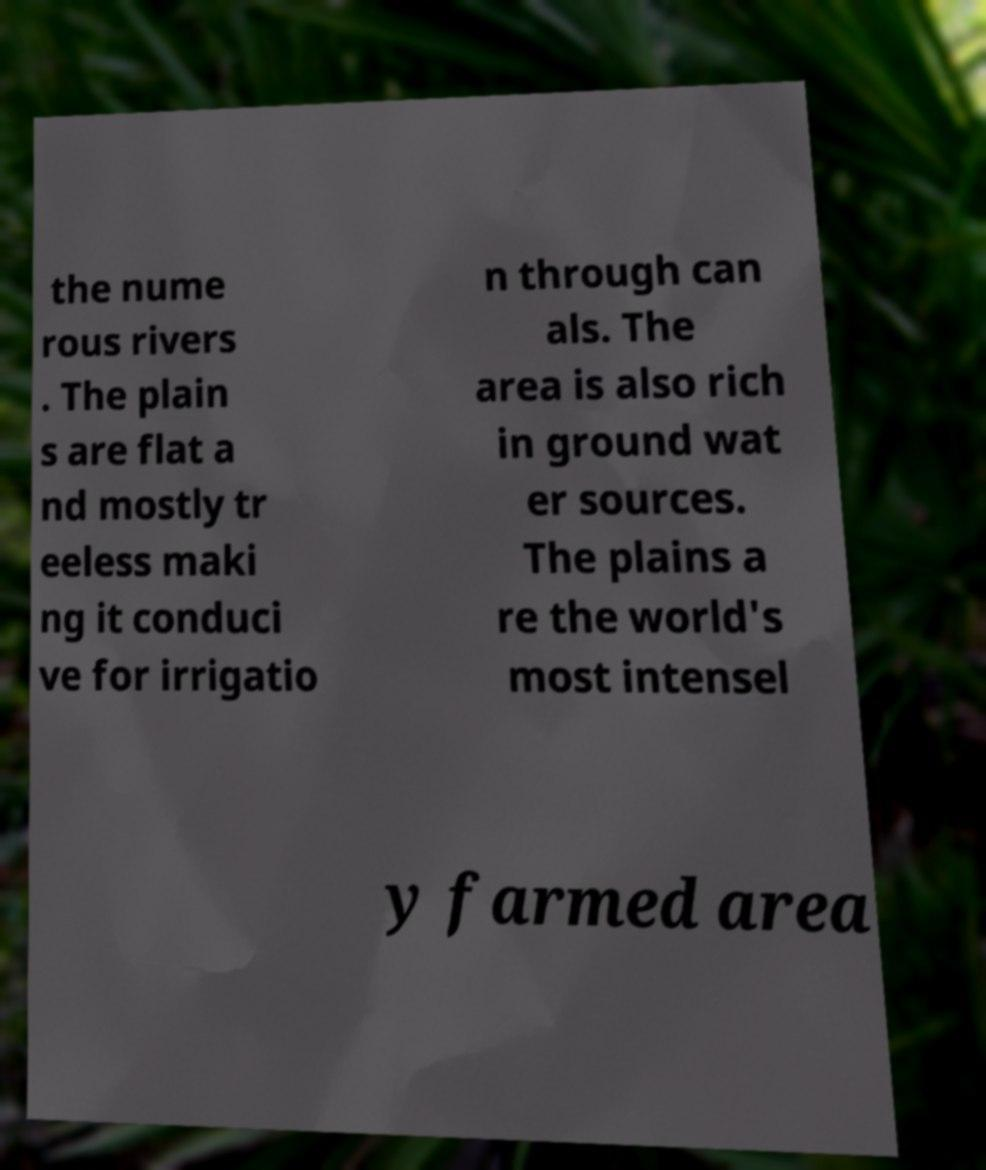What messages or text are displayed in this image? I need them in a readable, typed format. the nume rous rivers . The plain s are flat a nd mostly tr eeless maki ng it conduci ve for irrigatio n through can als. The area is also rich in ground wat er sources. The plains a re the world's most intensel y farmed area 